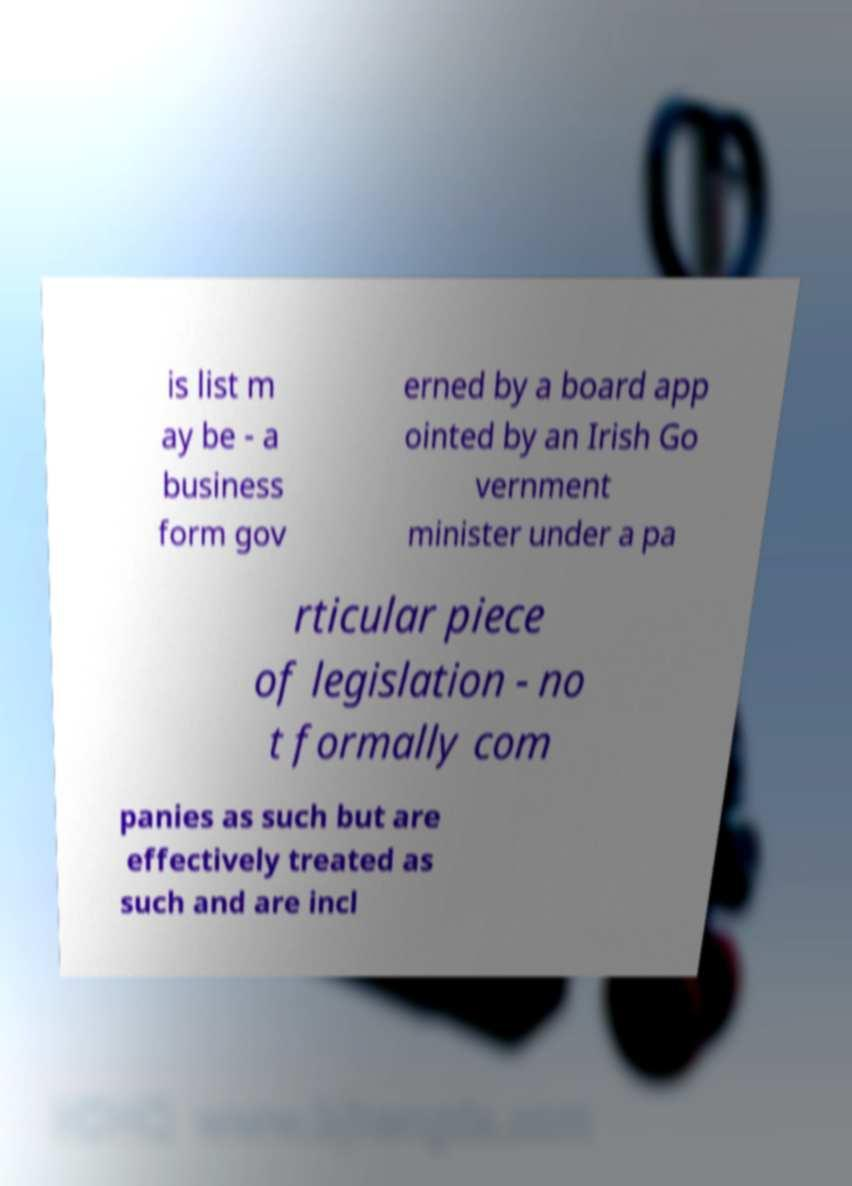Could you extract and type out the text from this image? is list m ay be - a business form gov erned by a board app ointed by an Irish Go vernment minister under a pa rticular piece of legislation - no t formally com panies as such but are effectively treated as such and are incl 